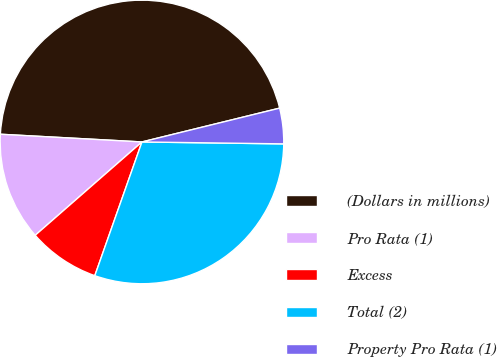Convert chart to OTSL. <chart><loc_0><loc_0><loc_500><loc_500><pie_chart><fcel>(Dollars in millions)<fcel>Pro Rata (1)<fcel>Excess<fcel>Total (2)<fcel>Property Pro Rata (1)<nl><fcel>45.3%<fcel>12.3%<fcel>8.17%<fcel>30.18%<fcel>4.05%<nl></chart> 